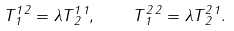<formula> <loc_0><loc_0><loc_500><loc_500>T ^ { 1 \, 2 } _ { \, 1 } = \lambda T ^ { 1 \, 1 } _ { \, 2 } , \quad T ^ { 2 \, 2 } _ { \, 1 } = \lambda T ^ { 2 \, 1 } _ { \, 2 } .</formula> 